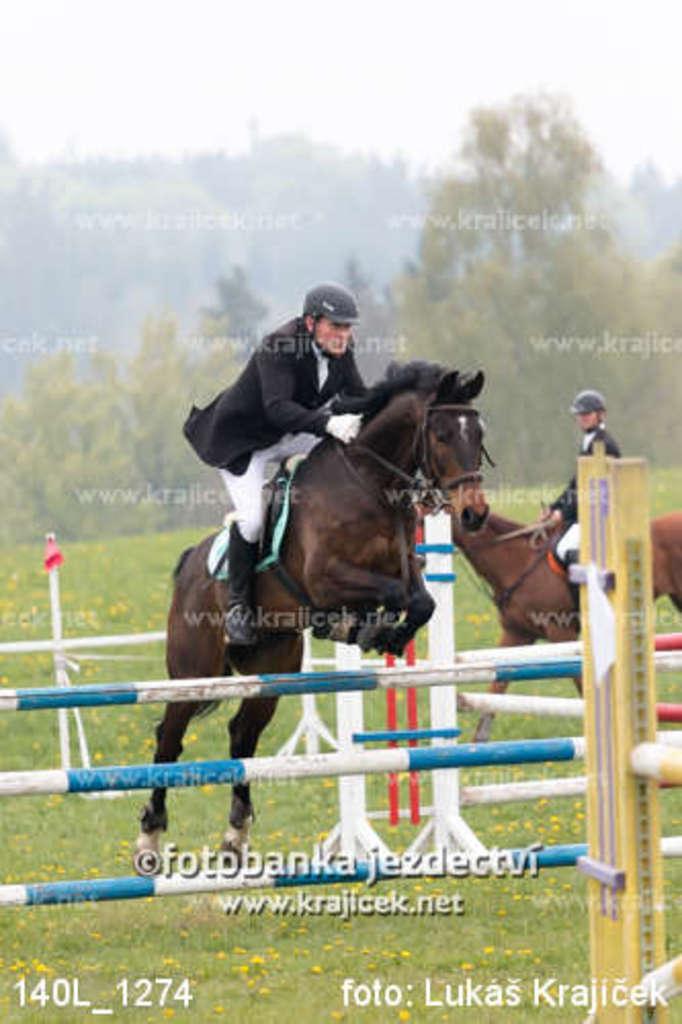Could you give a brief overview of what you see in this image? In this image, I can see two people riding the horses. I think these are the kind of hurdles. This is the grass. I can see the watermarks on the image. In the background, I think these are the trees. 